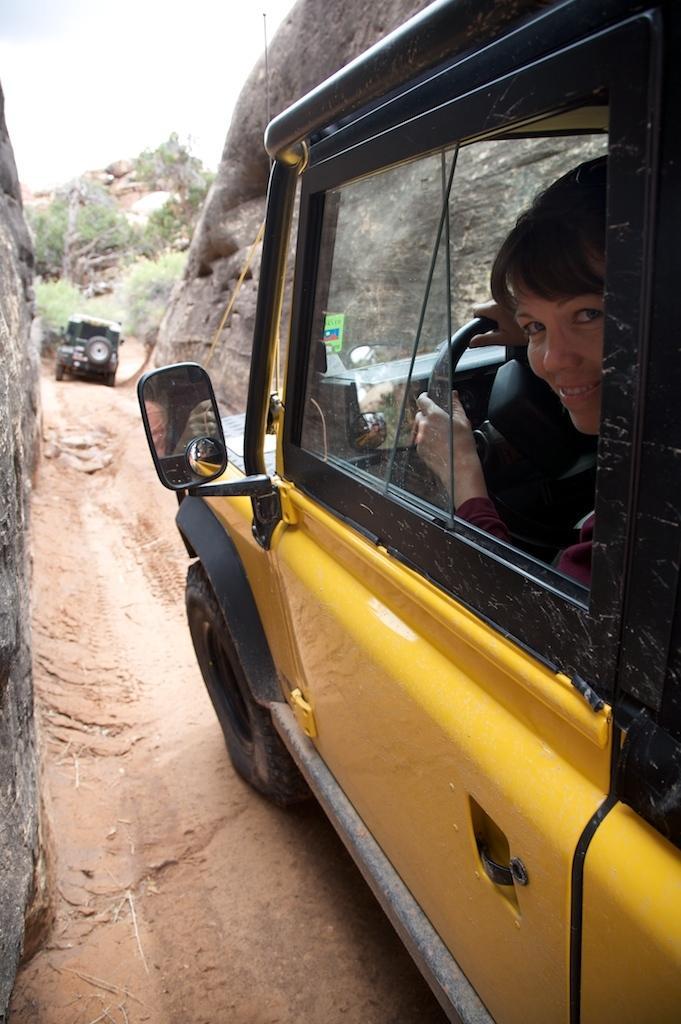Describe this image in one or two sentences. In this picture, There is a car which is in yellow color in that car there is a woman sitting and holding the steering wheel, In the background there is a road, There are mountain in black color, There are some green color trees and there is sky in white color. 